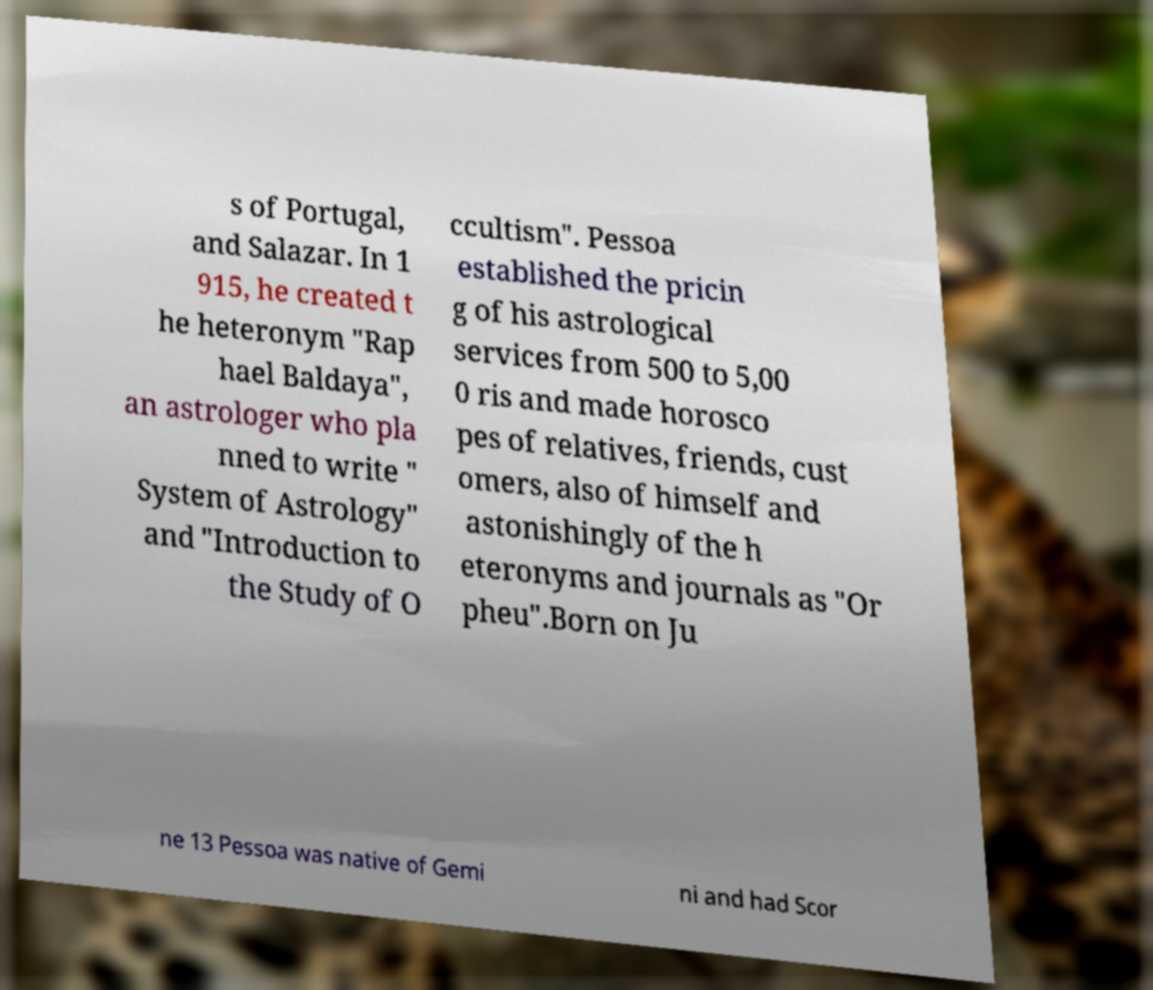Could you extract and type out the text from this image? s of Portugal, and Salazar. In 1 915, he created t he heteronym "Rap hael Baldaya", an astrologer who pla nned to write " System of Astrology" and "Introduction to the Study of O ccultism". Pessoa established the pricin g of his astrological services from 500 to 5,00 0 ris and made horosco pes of relatives, friends, cust omers, also of himself and astonishingly of the h eteronyms and journals as "Or pheu".Born on Ju ne 13 Pessoa was native of Gemi ni and had Scor 